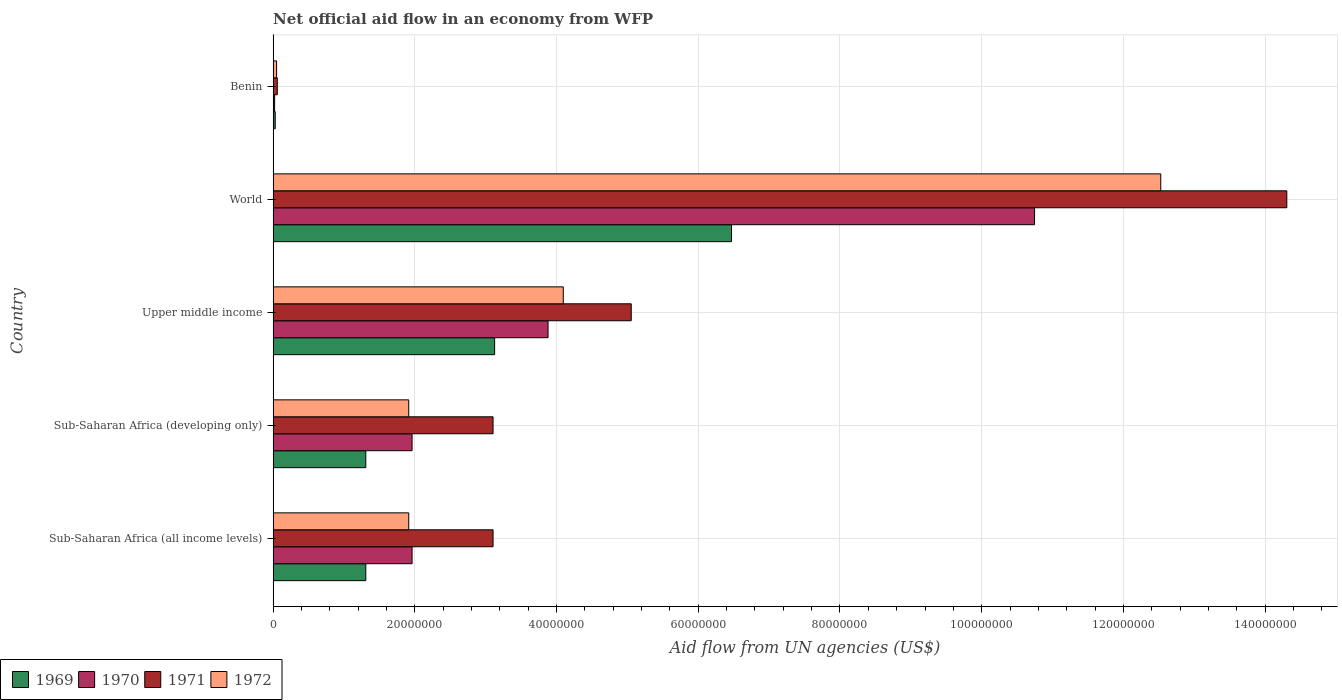How many different coloured bars are there?
Offer a terse response. 4. How many groups of bars are there?
Your answer should be compact. 5. How many bars are there on the 2nd tick from the bottom?
Ensure brevity in your answer.  4. What is the label of the 4th group of bars from the top?
Provide a short and direct response. Sub-Saharan Africa (developing only). In how many cases, is the number of bars for a given country not equal to the number of legend labels?
Give a very brief answer. 0. Across all countries, what is the maximum net official aid flow in 1971?
Your answer should be very brief. 1.43e+08. Across all countries, what is the minimum net official aid flow in 1970?
Your answer should be compact. 2.10e+05. In which country was the net official aid flow in 1969 maximum?
Make the answer very short. World. In which country was the net official aid flow in 1971 minimum?
Make the answer very short. Benin. What is the total net official aid flow in 1971 in the graph?
Make the answer very short. 2.56e+08. What is the difference between the net official aid flow in 1971 in Benin and that in World?
Ensure brevity in your answer.  -1.42e+08. What is the difference between the net official aid flow in 1970 in World and the net official aid flow in 1969 in Upper middle income?
Your answer should be very brief. 7.62e+07. What is the average net official aid flow in 1969 per country?
Offer a terse response. 2.45e+07. What is the difference between the net official aid flow in 1969 and net official aid flow in 1972 in Sub-Saharan Africa (all income levels)?
Offer a very short reply. -6.06e+06. In how many countries, is the net official aid flow in 1969 greater than 100000000 US$?
Offer a very short reply. 0. What is the ratio of the net official aid flow in 1972 in Benin to that in Sub-Saharan Africa (developing only)?
Give a very brief answer. 0.03. Is the net official aid flow in 1971 in Benin less than that in Sub-Saharan Africa (all income levels)?
Keep it short and to the point. Yes. Is the difference between the net official aid flow in 1969 in Benin and Sub-Saharan Africa (developing only) greater than the difference between the net official aid flow in 1972 in Benin and Sub-Saharan Africa (developing only)?
Give a very brief answer. Yes. What is the difference between the highest and the second highest net official aid flow in 1971?
Your answer should be very brief. 9.25e+07. What is the difference between the highest and the lowest net official aid flow in 1970?
Your answer should be compact. 1.07e+08. In how many countries, is the net official aid flow in 1971 greater than the average net official aid flow in 1971 taken over all countries?
Provide a succinct answer. 1. Is the sum of the net official aid flow in 1969 in Benin and Upper middle income greater than the maximum net official aid flow in 1970 across all countries?
Ensure brevity in your answer.  No. Is it the case that in every country, the sum of the net official aid flow in 1969 and net official aid flow in 1970 is greater than the sum of net official aid flow in 1971 and net official aid flow in 1972?
Provide a short and direct response. No. What does the 2nd bar from the top in World represents?
Your response must be concise. 1971. What does the 2nd bar from the bottom in Sub-Saharan Africa (developing only) represents?
Ensure brevity in your answer.  1970. Is it the case that in every country, the sum of the net official aid flow in 1969 and net official aid flow in 1970 is greater than the net official aid flow in 1971?
Provide a short and direct response. No. How many bars are there?
Give a very brief answer. 20. Does the graph contain any zero values?
Make the answer very short. No. Does the graph contain grids?
Your response must be concise. Yes. Where does the legend appear in the graph?
Your answer should be compact. Bottom left. How are the legend labels stacked?
Make the answer very short. Horizontal. What is the title of the graph?
Make the answer very short. Net official aid flow in an economy from WFP. What is the label or title of the X-axis?
Your response must be concise. Aid flow from UN agencies (US$). What is the label or title of the Y-axis?
Give a very brief answer. Country. What is the Aid flow from UN agencies (US$) in 1969 in Sub-Saharan Africa (all income levels)?
Ensure brevity in your answer.  1.31e+07. What is the Aid flow from UN agencies (US$) of 1970 in Sub-Saharan Africa (all income levels)?
Give a very brief answer. 1.96e+07. What is the Aid flow from UN agencies (US$) in 1971 in Sub-Saharan Africa (all income levels)?
Your answer should be compact. 3.10e+07. What is the Aid flow from UN agencies (US$) of 1972 in Sub-Saharan Africa (all income levels)?
Ensure brevity in your answer.  1.91e+07. What is the Aid flow from UN agencies (US$) of 1969 in Sub-Saharan Africa (developing only)?
Offer a very short reply. 1.31e+07. What is the Aid flow from UN agencies (US$) in 1970 in Sub-Saharan Africa (developing only)?
Make the answer very short. 1.96e+07. What is the Aid flow from UN agencies (US$) of 1971 in Sub-Saharan Africa (developing only)?
Offer a very short reply. 3.10e+07. What is the Aid flow from UN agencies (US$) in 1972 in Sub-Saharan Africa (developing only)?
Give a very brief answer. 1.91e+07. What is the Aid flow from UN agencies (US$) in 1969 in Upper middle income?
Ensure brevity in your answer.  3.13e+07. What is the Aid flow from UN agencies (US$) of 1970 in Upper middle income?
Offer a terse response. 3.88e+07. What is the Aid flow from UN agencies (US$) of 1971 in Upper middle income?
Make the answer very short. 5.05e+07. What is the Aid flow from UN agencies (US$) in 1972 in Upper middle income?
Give a very brief answer. 4.10e+07. What is the Aid flow from UN agencies (US$) of 1969 in World?
Your response must be concise. 6.47e+07. What is the Aid flow from UN agencies (US$) of 1970 in World?
Your response must be concise. 1.07e+08. What is the Aid flow from UN agencies (US$) in 1971 in World?
Make the answer very short. 1.43e+08. What is the Aid flow from UN agencies (US$) in 1972 in World?
Offer a terse response. 1.25e+08. What is the Aid flow from UN agencies (US$) of 1969 in Benin?
Keep it short and to the point. 3.00e+05. What is the Aid flow from UN agencies (US$) of 1970 in Benin?
Give a very brief answer. 2.10e+05. What is the Aid flow from UN agencies (US$) of 1971 in Benin?
Your answer should be very brief. 5.90e+05. What is the Aid flow from UN agencies (US$) in 1972 in Benin?
Offer a very short reply. 4.90e+05. Across all countries, what is the maximum Aid flow from UN agencies (US$) of 1969?
Your answer should be very brief. 6.47e+07. Across all countries, what is the maximum Aid flow from UN agencies (US$) in 1970?
Give a very brief answer. 1.07e+08. Across all countries, what is the maximum Aid flow from UN agencies (US$) of 1971?
Give a very brief answer. 1.43e+08. Across all countries, what is the maximum Aid flow from UN agencies (US$) of 1972?
Your answer should be compact. 1.25e+08. Across all countries, what is the minimum Aid flow from UN agencies (US$) of 1971?
Give a very brief answer. 5.90e+05. What is the total Aid flow from UN agencies (US$) in 1969 in the graph?
Make the answer very short. 1.22e+08. What is the total Aid flow from UN agencies (US$) of 1970 in the graph?
Ensure brevity in your answer.  1.86e+08. What is the total Aid flow from UN agencies (US$) of 1971 in the graph?
Your response must be concise. 2.56e+08. What is the total Aid flow from UN agencies (US$) of 1972 in the graph?
Ensure brevity in your answer.  2.05e+08. What is the difference between the Aid flow from UN agencies (US$) in 1971 in Sub-Saharan Africa (all income levels) and that in Sub-Saharan Africa (developing only)?
Your answer should be compact. 0. What is the difference between the Aid flow from UN agencies (US$) of 1972 in Sub-Saharan Africa (all income levels) and that in Sub-Saharan Africa (developing only)?
Make the answer very short. 0. What is the difference between the Aid flow from UN agencies (US$) of 1969 in Sub-Saharan Africa (all income levels) and that in Upper middle income?
Your response must be concise. -1.82e+07. What is the difference between the Aid flow from UN agencies (US$) in 1970 in Sub-Saharan Africa (all income levels) and that in Upper middle income?
Ensure brevity in your answer.  -1.92e+07. What is the difference between the Aid flow from UN agencies (US$) in 1971 in Sub-Saharan Africa (all income levels) and that in Upper middle income?
Your answer should be compact. -1.95e+07. What is the difference between the Aid flow from UN agencies (US$) in 1972 in Sub-Saharan Africa (all income levels) and that in Upper middle income?
Provide a succinct answer. -2.18e+07. What is the difference between the Aid flow from UN agencies (US$) of 1969 in Sub-Saharan Africa (all income levels) and that in World?
Keep it short and to the point. -5.16e+07. What is the difference between the Aid flow from UN agencies (US$) of 1970 in Sub-Saharan Africa (all income levels) and that in World?
Make the answer very short. -8.78e+07. What is the difference between the Aid flow from UN agencies (US$) of 1971 in Sub-Saharan Africa (all income levels) and that in World?
Provide a short and direct response. -1.12e+08. What is the difference between the Aid flow from UN agencies (US$) of 1972 in Sub-Saharan Africa (all income levels) and that in World?
Keep it short and to the point. -1.06e+08. What is the difference between the Aid flow from UN agencies (US$) in 1969 in Sub-Saharan Africa (all income levels) and that in Benin?
Your response must be concise. 1.28e+07. What is the difference between the Aid flow from UN agencies (US$) of 1970 in Sub-Saharan Africa (all income levels) and that in Benin?
Offer a terse response. 1.94e+07. What is the difference between the Aid flow from UN agencies (US$) in 1971 in Sub-Saharan Africa (all income levels) and that in Benin?
Ensure brevity in your answer.  3.04e+07. What is the difference between the Aid flow from UN agencies (US$) of 1972 in Sub-Saharan Africa (all income levels) and that in Benin?
Your response must be concise. 1.86e+07. What is the difference between the Aid flow from UN agencies (US$) of 1969 in Sub-Saharan Africa (developing only) and that in Upper middle income?
Your answer should be very brief. -1.82e+07. What is the difference between the Aid flow from UN agencies (US$) in 1970 in Sub-Saharan Africa (developing only) and that in Upper middle income?
Your answer should be compact. -1.92e+07. What is the difference between the Aid flow from UN agencies (US$) of 1971 in Sub-Saharan Africa (developing only) and that in Upper middle income?
Your answer should be compact. -1.95e+07. What is the difference between the Aid flow from UN agencies (US$) in 1972 in Sub-Saharan Africa (developing only) and that in Upper middle income?
Offer a very short reply. -2.18e+07. What is the difference between the Aid flow from UN agencies (US$) of 1969 in Sub-Saharan Africa (developing only) and that in World?
Offer a terse response. -5.16e+07. What is the difference between the Aid flow from UN agencies (US$) of 1970 in Sub-Saharan Africa (developing only) and that in World?
Provide a succinct answer. -8.78e+07. What is the difference between the Aid flow from UN agencies (US$) of 1971 in Sub-Saharan Africa (developing only) and that in World?
Provide a succinct answer. -1.12e+08. What is the difference between the Aid flow from UN agencies (US$) in 1972 in Sub-Saharan Africa (developing only) and that in World?
Offer a very short reply. -1.06e+08. What is the difference between the Aid flow from UN agencies (US$) in 1969 in Sub-Saharan Africa (developing only) and that in Benin?
Offer a terse response. 1.28e+07. What is the difference between the Aid flow from UN agencies (US$) in 1970 in Sub-Saharan Africa (developing only) and that in Benin?
Provide a succinct answer. 1.94e+07. What is the difference between the Aid flow from UN agencies (US$) in 1971 in Sub-Saharan Africa (developing only) and that in Benin?
Offer a terse response. 3.04e+07. What is the difference between the Aid flow from UN agencies (US$) in 1972 in Sub-Saharan Africa (developing only) and that in Benin?
Keep it short and to the point. 1.86e+07. What is the difference between the Aid flow from UN agencies (US$) of 1969 in Upper middle income and that in World?
Provide a succinct answer. -3.34e+07. What is the difference between the Aid flow from UN agencies (US$) in 1970 in Upper middle income and that in World?
Your answer should be very brief. -6.87e+07. What is the difference between the Aid flow from UN agencies (US$) of 1971 in Upper middle income and that in World?
Offer a terse response. -9.25e+07. What is the difference between the Aid flow from UN agencies (US$) in 1972 in Upper middle income and that in World?
Your answer should be compact. -8.43e+07. What is the difference between the Aid flow from UN agencies (US$) of 1969 in Upper middle income and that in Benin?
Provide a succinct answer. 3.10e+07. What is the difference between the Aid flow from UN agencies (US$) in 1970 in Upper middle income and that in Benin?
Your answer should be compact. 3.86e+07. What is the difference between the Aid flow from UN agencies (US$) of 1971 in Upper middle income and that in Benin?
Keep it short and to the point. 5.00e+07. What is the difference between the Aid flow from UN agencies (US$) of 1972 in Upper middle income and that in Benin?
Offer a terse response. 4.05e+07. What is the difference between the Aid flow from UN agencies (US$) of 1969 in World and that in Benin?
Provide a short and direct response. 6.44e+07. What is the difference between the Aid flow from UN agencies (US$) in 1970 in World and that in Benin?
Keep it short and to the point. 1.07e+08. What is the difference between the Aid flow from UN agencies (US$) in 1971 in World and that in Benin?
Give a very brief answer. 1.42e+08. What is the difference between the Aid flow from UN agencies (US$) in 1972 in World and that in Benin?
Offer a terse response. 1.25e+08. What is the difference between the Aid flow from UN agencies (US$) of 1969 in Sub-Saharan Africa (all income levels) and the Aid flow from UN agencies (US$) of 1970 in Sub-Saharan Africa (developing only)?
Your answer should be very brief. -6.53e+06. What is the difference between the Aid flow from UN agencies (US$) in 1969 in Sub-Saharan Africa (all income levels) and the Aid flow from UN agencies (US$) in 1971 in Sub-Saharan Africa (developing only)?
Your answer should be very brief. -1.80e+07. What is the difference between the Aid flow from UN agencies (US$) in 1969 in Sub-Saharan Africa (all income levels) and the Aid flow from UN agencies (US$) in 1972 in Sub-Saharan Africa (developing only)?
Ensure brevity in your answer.  -6.06e+06. What is the difference between the Aid flow from UN agencies (US$) of 1970 in Sub-Saharan Africa (all income levels) and the Aid flow from UN agencies (US$) of 1971 in Sub-Saharan Africa (developing only)?
Ensure brevity in your answer.  -1.14e+07. What is the difference between the Aid flow from UN agencies (US$) in 1971 in Sub-Saharan Africa (all income levels) and the Aid flow from UN agencies (US$) in 1972 in Sub-Saharan Africa (developing only)?
Your answer should be compact. 1.19e+07. What is the difference between the Aid flow from UN agencies (US$) of 1969 in Sub-Saharan Africa (all income levels) and the Aid flow from UN agencies (US$) of 1970 in Upper middle income?
Ensure brevity in your answer.  -2.57e+07. What is the difference between the Aid flow from UN agencies (US$) of 1969 in Sub-Saharan Africa (all income levels) and the Aid flow from UN agencies (US$) of 1971 in Upper middle income?
Provide a succinct answer. -3.75e+07. What is the difference between the Aid flow from UN agencies (US$) in 1969 in Sub-Saharan Africa (all income levels) and the Aid flow from UN agencies (US$) in 1972 in Upper middle income?
Keep it short and to the point. -2.79e+07. What is the difference between the Aid flow from UN agencies (US$) in 1970 in Sub-Saharan Africa (all income levels) and the Aid flow from UN agencies (US$) in 1971 in Upper middle income?
Provide a short and direct response. -3.09e+07. What is the difference between the Aid flow from UN agencies (US$) in 1970 in Sub-Saharan Africa (all income levels) and the Aid flow from UN agencies (US$) in 1972 in Upper middle income?
Your answer should be very brief. -2.13e+07. What is the difference between the Aid flow from UN agencies (US$) in 1971 in Sub-Saharan Africa (all income levels) and the Aid flow from UN agencies (US$) in 1972 in Upper middle income?
Make the answer very short. -9.91e+06. What is the difference between the Aid flow from UN agencies (US$) of 1969 in Sub-Saharan Africa (all income levels) and the Aid flow from UN agencies (US$) of 1970 in World?
Your answer should be compact. -9.44e+07. What is the difference between the Aid flow from UN agencies (US$) in 1969 in Sub-Saharan Africa (all income levels) and the Aid flow from UN agencies (US$) in 1971 in World?
Provide a succinct answer. -1.30e+08. What is the difference between the Aid flow from UN agencies (US$) in 1969 in Sub-Saharan Africa (all income levels) and the Aid flow from UN agencies (US$) in 1972 in World?
Make the answer very short. -1.12e+08. What is the difference between the Aid flow from UN agencies (US$) of 1970 in Sub-Saharan Africa (all income levels) and the Aid flow from UN agencies (US$) of 1971 in World?
Your answer should be compact. -1.23e+08. What is the difference between the Aid flow from UN agencies (US$) in 1970 in Sub-Saharan Africa (all income levels) and the Aid flow from UN agencies (US$) in 1972 in World?
Your response must be concise. -1.06e+08. What is the difference between the Aid flow from UN agencies (US$) in 1971 in Sub-Saharan Africa (all income levels) and the Aid flow from UN agencies (US$) in 1972 in World?
Keep it short and to the point. -9.42e+07. What is the difference between the Aid flow from UN agencies (US$) of 1969 in Sub-Saharan Africa (all income levels) and the Aid flow from UN agencies (US$) of 1970 in Benin?
Keep it short and to the point. 1.29e+07. What is the difference between the Aid flow from UN agencies (US$) of 1969 in Sub-Saharan Africa (all income levels) and the Aid flow from UN agencies (US$) of 1971 in Benin?
Give a very brief answer. 1.25e+07. What is the difference between the Aid flow from UN agencies (US$) in 1969 in Sub-Saharan Africa (all income levels) and the Aid flow from UN agencies (US$) in 1972 in Benin?
Provide a succinct answer. 1.26e+07. What is the difference between the Aid flow from UN agencies (US$) of 1970 in Sub-Saharan Africa (all income levels) and the Aid flow from UN agencies (US$) of 1971 in Benin?
Your answer should be compact. 1.90e+07. What is the difference between the Aid flow from UN agencies (US$) in 1970 in Sub-Saharan Africa (all income levels) and the Aid flow from UN agencies (US$) in 1972 in Benin?
Ensure brevity in your answer.  1.91e+07. What is the difference between the Aid flow from UN agencies (US$) in 1971 in Sub-Saharan Africa (all income levels) and the Aid flow from UN agencies (US$) in 1972 in Benin?
Offer a very short reply. 3.06e+07. What is the difference between the Aid flow from UN agencies (US$) of 1969 in Sub-Saharan Africa (developing only) and the Aid flow from UN agencies (US$) of 1970 in Upper middle income?
Your response must be concise. -2.57e+07. What is the difference between the Aid flow from UN agencies (US$) in 1969 in Sub-Saharan Africa (developing only) and the Aid flow from UN agencies (US$) in 1971 in Upper middle income?
Offer a terse response. -3.75e+07. What is the difference between the Aid flow from UN agencies (US$) of 1969 in Sub-Saharan Africa (developing only) and the Aid flow from UN agencies (US$) of 1972 in Upper middle income?
Ensure brevity in your answer.  -2.79e+07. What is the difference between the Aid flow from UN agencies (US$) of 1970 in Sub-Saharan Africa (developing only) and the Aid flow from UN agencies (US$) of 1971 in Upper middle income?
Keep it short and to the point. -3.09e+07. What is the difference between the Aid flow from UN agencies (US$) in 1970 in Sub-Saharan Africa (developing only) and the Aid flow from UN agencies (US$) in 1972 in Upper middle income?
Ensure brevity in your answer.  -2.13e+07. What is the difference between the Aid flow from UN agencies (US$) in 1971 in Sub-Saharan Africa (developing only) and the Aid flow from UN agencies (US$) in 1972 in Upper middle income?
Keep it short and to the point. -9.91e+06. What is the difference between the Aid flow from UN agencies (US$) of 1969 in Sub-Saharan Africa (developing only) and the Aid flow from UN agencies (US$) of 1970 in World?
Give a very brief answer. -9.44e+07. What is the difference between the Aid flow from UN agencies (US$) in 1969 in Sub-Saharan Africa (developing only) and the Aid flow from UN agencies (US$) in 1971 in World?
Provide a short and direct response. -1.30e+08. What is the difference between the Aid flow from UN agencies (US$) in 1969 in Sub-Saharan Africa (developing only) and the Aid flow from UN agencies (US$) in 1972 in World?
Ensure brevity in your answer.  -1.12e+08. What is the difference between the Aid flow from UN agencies (US$) in 1970 in Sub-Saharan Africa (developing only) and the Aid flow from UN agencies (US$) in 1971 in World?
Your answer should be very brief. -1.23e+08. What is the difference between the Aid flow from UN agencies (US$) in 1970 in Sub-Saharan Africa (developing only) and the Aid flow from UN agencies (US$) in 1972 in World?
Provide a short and direct response. -1.06e+08. What is the difference between the Aid flow from UN agencies (US$) of 1971 in Sub-Saharan Africa (developing only) and the Aid flow from UN agencies (US$) of 1972 in World?
Provide a short and direct response. -9.42e+07. What is the difference between the Aid flow from UN agencies (US$) in 1969 in Sub-Saharan Africa (developing only) and the Aid flow from UN agencies (US$) in 1970 in Benin?
Your answer should be very brief. 1.29e+07. What is the difference between the Aid flow from UN agencies (US$) in 1969 in Sub-Saharan Africa (developing only) and the Aid flow from UN agencies (US$) in 1971 in Benin?
Make the answer very short. 1.25e+07. What is the difference between the Aid flow from UN agencies (US$) of 1969 in Sub-Saharan Africa (developing only) and the Aid flow from UN agencies (US$) of 1972 in Benin?
Your answer should be compact. 1.26e+07. What is the difference between the Aid flow from UN agencies (US$) of 1970 in Sub-Saharan Africa (developing only) and the Aid flow from UN agencies (US$) of 1971 in Benin?
Make the answer very short. 1.90e+07. What is the difference between the Aid flow from UN agencies (US$) of 1970 in Sub-Saharan Africa (developing only) and the Aid flow from UN agencies (US$) of 1972 in Benin?
Your answer should be compact. 1.91e+07. What is the difference between the Aid flow from UN agencies (US$) of 1971 in Sub-Saharan Africa (developing only) and the Aid flow from UN agencies (US$) of 1972 in Benin?
Ensure brevity in your answer.  3.06e+07. What is the difference between the Aid flow from UN agencies (US$) in 1969 in Upper middle income and the Aid flow from UN agencies (US$) in 1970 in World?
Provide a short and direct response. -7.62e+07. What is the difference between the Aid flow from UN agencies (US$) in 1969 in Upper middle income and the Aid flow from UN agencies (US$) in 1971 in World?
Offer a terse response. -1.12e+08. What is the difference between the Aid flow from UN agencies (US$) of 1969 in Upper middle income and the Aid flow from UN agencies (US$) of 1972 in World?
Offer a very short reply. -9.40e+07. What is the difference between the Aid flow from UN agencies (US$) in 1970 in Upper middle income and the Aid flow from UN agencies (US$) in 1971 in World?
Ensure brevity in your answer.  -1.04e+08. What is the difference between the Aid flow from UN agencies (US$) in 1970 in Upper middle income and the Aid flow from UN agencies (US$) in 1972 in World?
Make the answer very short. -8.65e+07. What is the difference between the Aid flow from UN agencies (US$) in 1971 in Upper middle income and the Aid flow from UN agencies (US$) in 1972 in World?
Offer a terse response. -7.47e+07. What is the difference between the Aid flow from UN agencies (US$) of 1969 in Upper middle income and the Aid flow from UN agencies (US$) of 1970 in Benin?
Offer a very short reply. 3.10e+07. What is the difference between the Aid flow from UN agencies (US$) in 1969 in Upper middle income and the Aid flow from UN agencies (US$) in 1971 in Benin?
Offer a terse response. 3.07e+07. What is the difference between the Aid flow from UN agencies (US$) in 1969 in Upper middle income and the Aid flow from UN agencies (US$) in 1972 in Benin?
Keep it short and to the point. 3.08e+07. What is the difference between the Aid flow from UN agencies (US$) in 1970 in Upper middle income and the Aid flow from UN agencies (US$) in 1971 in Benin?
Make the answer very short. 3.82e+07. What is the difference between the Aid flow from UN agencies (US$) of 1970 in Upper middle income and the Aid flow from UN agencies (US$) of 1972 in Benin?
Offer a very short reply. 3.83e+07. What is the difference between the Aid flow from UN agencies (US$) of 1971 in Upper middle income and the Aid flow from UN agencies (US$) of 1972 in Benin?
Your answer should be compact. 5.00e+07. What is the difference between the Aid flow from UN agencies (US$) of 1969 in World and the Aid flow from UN agencies (US$) of 1970 in Benin?
Make the answer very short. 6.45e+07. What is the difference between the Aid flow from UN agencies (US$) in 1969 in World and the Aid flow from UN agencies (US$) in 1971 in Benin?
Offer a terse response. 6.41e+07. What is the difference between the Aid flow from UN agencies (US$) of 1969 in World and the Aid flow from UN agencies (US$) of 1972 in Benin?
Give a very brief answer. 6.42e+07. What is the difference between the Aid flow from UN agencies (US$) of 1970 in World and the Aid flow from UN agencies (US$) of 1971 in Benin?
Keep it short and to the point. 1.07e+08. What is the difference between the Aid flow from UN agencies (US$) of 1970 in World and the Aid flow from UN agencies (US$) of 1972 in Benin?
Give a very brief answer. 1.07e+08. What is the difference between the Aid flow from UN agencies (US$) of 1971 in World and the Aid flow from UN agencies (US$) of 1972 in Benin?
Provide a short and direct response. 1.43e+08. What is the average Aid flow from UN agencies (US$) in 1969 per country?
Your answer should be very brief. 2.45e+07. What is the average Aid flow from UN agencies (US$) of 1970 per country?
Provide a succinct answer. 3.71e+07. What is the average Aid flow from UN agencies (US$) of 1971 per country?
Give a very brief answer. 5.13e+07. What is the average Aid flow from UN agencies (US$) of 1972 per country?
Your response must be concise. 4.10e+07. What is the difference between the Aid flow from UN agencies (US$) in 1969 and Aid flow from UN agencies (US$) in 1970 in Sub-Saharan Africa (all income levels)?
Your response must be concise. -6.53e+06. What is the difference between the Aid flow from UN agencies (US$) in 1969 and Aid flow from UN agencies (US$) in 1971 in Sub-Saharan Africa (all income levels)?
Your answer should be compact. -1.80e+07. What is the difference between the Aid flow from UN agencies (US$) in 1969 and Aid flow from UN agencies (US$) in 1972 in Sub-Saharan Africa (all income levels)?
Your response must be concise. -6.06e+06. What is the difference between the Aid flow from UN agencies (US$) of 1970 and Aid flow from UN agencies (US$) of 1971 in Sub-Saharan Africa (all income levels)?
Make the answer very short. -1.14e+07. What is the difference between the Aid flow from UN agencies (US$) in 1971 and Aid flow from UN agencies (US$) in 1972 in Sub-Saharan Africa (all income levels)?
Provide a short and direct response. 1.19e+07. What is the difference between the Aid flow from UN agencies (US$) of 1969 and Aid flow from UN agencies (US$) of 1970 in Sub-Saharan Africa (developing only)?
Make the answer very short. -6.53e+06. What is the difference between the Aid flow from UN agencies (US$) of 1969 and Aid flow from UN agencies (US$) of 1971 in Sub-Saharan Africa (developing only)?
Make the answer very short. -1.80e+07. What is the difference between the Aid flow from UN agencies (US$) of 1969 and Aid flow from UN agencies (US$) of 1972 in Sub-Saharan Africa (developing only)?
Provide a succinct answer. -6.06e+06. What is the difference between the Aid flow from UN agencies (US$) of 1970 and Aid flow from UN agencies (US$) of 1971 in Sub-Saharan Africa (developing only)?
Your answer should be compact. -1.14e+07. What is the difference between the Aid flow from UN agencies (US$) in 1970 and Aid flow from UN agencies (US$) in 1972 in Sub-Saharan Africa (developing only)?
Provide a succinct answer. 4.70e+05. What is the difference between the Aid flow from UN agencies (US$) of 1971 and Aid flow from UN agencies (US$) of 1972 in Sub-Saharan Africa (developing only)?
Make the answer very short. 1.19e+07. What is the difference between the Aid flow from UN agencies (US$) in 1969 and Aid flow from UN agencies (US$) in 1970 in Upper middle income?
Keep it short and to the point. -7.54e+06. What is the difference between the Aid flow from UN agencies (US$) of 1969 and Aid flow from UN agencies (US$) of 1971 in Upper middle income?
Your response must be concise. -1.93e+07. What is the difference between the Aid flow from UN agencies (US$) of 1969 and Aid flow from UN agencies (US$) of 1972 in Upper middle income?
Keep it short and to the point. -9.69e+06. What is the difference between the Aid flow from UN agencies (US$) in 1970 and Aid flow from UN agencies (US$) in 1971 in Upper middle income?
Your answer should be very brief. -1.17e+07. What is the difference between the Aid flow from UN agencies (US$) of 1970 and Aid flow from UN agencies (US$) of 1972 in Upper middle income?
Provide a short and direct response. -2.15e+06. What is the difference between the Aid flow from UN agencies (US$) in 1971 and Aid flow from UN agencies (US$) in 1972 in Upper middle income?
Your response must be concise. 9.59e+06. What is the difference between the Aid flow from UN agencies (US$) in 1969 and Aid flow from UN agencies (US$) in 1970 in World?
Your answer should be very brief. -4.28e+07. What is the difference between the Aid flow from UN agencies (US$) in 1969 and Aid flow from UN agencies (US$) in 1971 in World?
Your answer should be compact. -7.84e+07. What is the difference between the Aid flow from UN agencies (US$) in 1969 and Aid flow from UN agencies (US$) in 1972 in World?
Offer a terse response. -6.06e+07. What is the difference between the Aid flow from UN agencies (US$) of 1970 and Aid flow from UN agencies (US$) of 1971 in World?
Your response must be concise. -3.56e+07. What is the difference between the Aid flow from UN agencies (US$) of 1970 and Aid flow from UN agencies (US$) of 1972 in World?
Give a very brief answer. -1.78e+07. What is the difference between the Aid flow from UN agencies (US$) of 1971 and Aid flow from UN agencies (US$) of 1972 in World?
Offer a terse response. 1.78e+07. What is the difference between the Aid flow from UN agencies (US$) of 1969 and Aid flow from UN agencies (US$) of 1970 in Benin?
Keep it short and to the point. 9.00e+04. What is the difference between the Aid flow from UN agencies (US$) in 1970 and Aid flow from UN agencies (US$) in 1971 in Benin?
Ensure brevity in your answer.  -3.80e+05. What is the difference between the Aid flow from UN agencies (US$) in 1970 and Aid flow from UN agencies (US$) in 1972 in Benin?
Provide a short and direct response. -2.80e+05. What is the difference between the Aid flow from UN agencies (US$) of 1971 and Aid flow from UN agencies (US$) of 1972 in Benin?
Make the answer very short. 1.00e+05. What is the ratio of the Aid flow from UN agencies (US$) in 1969 in Sub-Saharan Africa (all income levels) to that in Sub-Saharan Africa (developing only)?
Your response must be concise. 1. What is the ratio of the Aid flow from UN agencies (US$) in 1970 in Sub-Saharan Africa (all income levels) to that in Sub-Saharan Africa (developing only)?
Give a very brief answer. 1. What is the ratio of the Aid flow from UN agencies (US$) in 1972 in Sub-Saharan Africa (all income levels) to that in Sub-Saharan Africa (developing only)?
Offer a very short reply. 1. What is the ratio of the Aid flow from UN agencies (US$) in 1969 in Sub-Saharan Africa (all income levels) to that in Upper middle income?
Offer a very short reply. 0.42. What is the ratio of the Aid flow from UN agencies (US$) of 1970 in Sub-Saharan Africa (all income levels) to that in Upper middle income?
Offer a terse response. 0.51. What is the ratio of the Aid flow from UN agencies (US$) of 1971 in Sub-Saharan Africa (all income levels) to that in Upper middle income?
Your response must be concise. 0.61. What is the ratio of the Aid flow from UN agencies (US$) in 1972 in Sub-Saharan Africa (all income levels) to that in Upper middle income?
Your answer should be compact. 0.47. What is the ratio of the Aid flow from UN agencies (US$) in 1969 in Sub-Saharan Africa (all income levels) to that in World?
Your answer should be compact. 0.2. What is the ratio of the Aid flow from UN agencies (US$) in 1970 in Sub-Saharan Africa (all income levels) to that in World?
Your response must be concise. 0.18. What is the ratio of the Aid flow from UN agencies (US$) in 1971 in Sub-Saharan Africa (all income levels) to that in World?
Make the answer very short. 0.22. What is the ratio of the Aid flow from UN agencies (US$) in 1972 in Sub-Saharan Africa (all income levels) to that in World?
Provide a short and direct response. 0.15. What is the ratio of the Aid flow from UN agencies (US$) of 1969 in Sub-Saharan Africa (all income levels) to that in Benin?
Ensure brevity in your answer.  43.6. What is the ratio of the Aid flow from UN agencies (US$) in 1970 in Sub-Saharan Africa (all income levels) to that in Benin?
Give a very brief answer. 93.38. What is the ratio of the Aid flow from UN agencies (US$) of 1971 in Sub-Saharan Africa (all income levels) to that in Benin?
Your answer should be very brief. 52.61. What is the ratio of the Aid flow from UN agencies (US$) of 1972 in Sub-Saharan Africa (all income levels) to that in Benin?
Your answer should be compact. 39.06. What is the ratio of the Aid flow from UN agencies (US$) in 1969 in Sub-Saharan Africa (developing only) to that in Upper middle income?
Your answer should be very brief. 0.42. What is the ratio of the Aid flow from UN agencies (US$) in 1970 in Sub-Saharan Africa (developing only) to that in Upper middle income?
Your response must be concise. 0.51. What is the ratio of the Aid flow from UN agencies (US$) of 1971 in Sub-Saharan Africa (developing only) to that in Upper middle income?
Your answer should be very brief. 0.61. What is the ratio of the Aid flow from UN agencies (US$) in 1972 in Sub-Saharan Africa (developing only) to that in Upper middle income?
Provide a succinct answer. 0.47. What is the ratio of the Aid flow from UN agencies (US$) of 1969 in Sub-Saharan Africa (developing only) to that in World?
Keep it short and to the point. 0.2. What is the ratio of the Aid flow from UN agencies (US$) in 1970 in Sub-Saharan Africa (developing only) to that in World?
Offer a terse response. 0.18. What is the ratio of the Aid flow from UN agencies (US$) in 1971 in Sub-Saharan Africa (developing only) to that in World?
Your answer should be very brief. 0.22. What is the ratio of the Aid flow from UN agencies (US$) in 1972 in Sub-Saharan Africa (developing only) to that in World?
Ensure brevity in your answer.  0.15. What is the ratio of the Aid flow from UN agencies (US$) of 1969 in Sub-Saharan Africa (developing only) to that in Benin?
Offer a terse response. 43.6. What is the ratio of the Aid flow from UN agencies (US$) of 1970 in Sub-Saharan Africa (developing only) to that in Benin?
Provide a succinct answer. 93.38. What is the ratio of the Aid flow from UN agencies (US$) in 1971 in Sub-Saharan Africa (developing only) to that in Benin?
Your response must be concise. 52.61. What is the ratio of the Aid flow from UN agencies (US$) in 1972 in Sub-Saharan Africa (developing only) to that in Benin?
Your answer should be very brief. 39.06. What is the ratio of the Aid flow from UN agencies (US$) of 1969 in Upper middle income to that in World?
Your answer should be very brief. 0.48. What is the ratio of the Aid flow from UN agencies (US$) of 1970 in Upper middle income to that in World?
Provide a short and direct response. 0.36. What is the ratio of the Aid flow from UN agencies (US$) of 1971 in Upper middle income to that in World?
Your answer should be very brief. 0.35. What is the ratio of the Aid flow from UN agencies (US$) of 1972 in Upper middle income to that in World?
Your response must be concise. 0.33. What is the ratio of the Aid flow from UN agencies (US$) in 1969 in Upper middle income to that in Benin?
Give a very brief answer. 104.2. What is the ratio of the Aid flow from UN agencies (US$) of 1970 in Upper middle income to that in Benin?
Ensure brevity in your answer.  184.76. What is the ratio of the Aid flow from UN agencies (US$) of 1971 in Upper middle income to that in Benin?
Your answer should be compact. 85.66. What is the ratio of the Aid flow from UN agencies (US$) in 1972 in Upper middle income to that in Benin?
Keep it short and to the point. 83.57. What is the ratio of the Aid flow from UN agencies (US$) in 1969 in World to that in Benin?
Offer a terse response. 215.63. What is the ratio of the Aid flow from UN agencies (US$) of 1970 in World to that in Benin?
Provide a succinct answer. 511.71. What is the ratio of the Aid flow from UN agencies (US$) of 1971 in World to that in Benin?
Ensure brevity in your answer.  242.47. What is the ratio of the Aid flow from UN agencies (US$) in 1972 in World to that in Benin?
Your answer should be very brief. 255.65. What is the difference between the highest and the second highest Aid flow from UN agencies (US$) in 1969?
Give a very brief answer. 3.34e+07. What is the difference between the highest and the second highest Aid flow from UN agencies (US$) of 1970?
Offer a very short reply. 6.87e+07. What is the difference between the highest and the second highest Aid flow from UN agencies (US$) of 1971?
Provide a short and direct response. 9.25e+07. What is the difference between the highest and the second highest Aid flow from UN agencies (US$) in 1972?
Provide a short and direct response. 8.43e+07. What is the difference between the highest and the lowest Aid flow from UN agencies (US$) of 1969?
Give a very brief answer. 6.44e+07. What is the difference between the highest and the lowest Aid flow from UN agencies (US$) in 1970?
Your answer should be very brief. 1.07e+08. What is the difference between the highest and the lowest Aid flow from UN agencies (US$) of 1971?
Your answer should be compact. 1.42e+08. What is the difference between the highest and the lowest Aid flow from UN agencies (US$) of 1972?
Make the answer very short. 1.25e+08. 